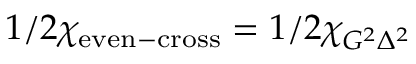Convert formula to latex. <formula><loc_0><loc_0><loc_500><loc_500>1 / 2 \chi _ { e v e n - c r o s s } = 1 / 2 \chi _ { G ^ { 2 } \Delta ^ { 2 } }</formula> 